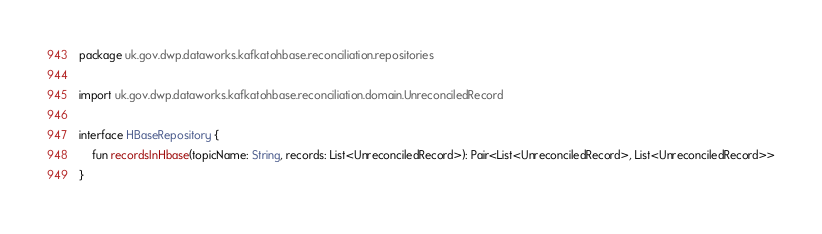<code> <loc_0><loc_0><loc_500><loc_500><_Kotlin_>package uk.gov.dwp.dataworks.kafkatohbase.reconciliation.repositories

import uk.gov.dwp.dataworks.kafkatohbase.reconciliation.domain.UnreconciledRecord

interface HBaseRepository {
    fun recordsInHbase(topicName: String, records: List<UnreconciledRecord>): Pair<List<UnreconciledRecord>, List<UnreconciledRecord>>
}
</code> 